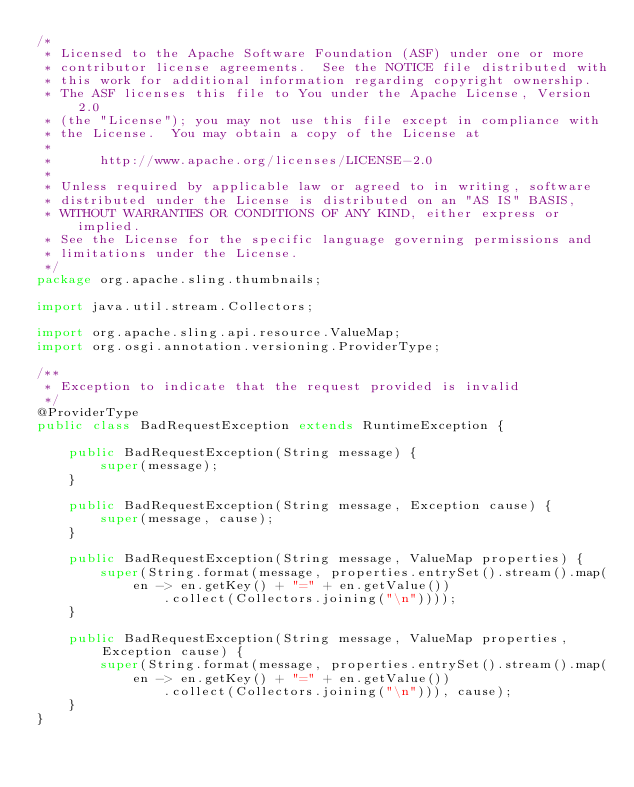<code> <loc_0><loc_0><loc_500><loc_500><_Java_>/*
 * Licensed to the Apache Software Foundation (ASF) under one or more
 * contributor license agreements.  See the NOTICE file distributed with
 * this work for additional information regarding copyright ownership.
 * The ASF licenses this file to You under the Apache License, Version 2.0
 * (the "License"); you may not use this file except in compliance with
 * the License.  You may obtain a copy of the License at
 *
 *      http://www.apache.org/licenses/LICENSE-2.0
 *
 * Unless required by applicable law or agreed to in writing, software
 * distributed under the License is distributed on an "AS IS" BASIS,
 * WITHOUT WARRANTIES OR CONDITIONS OF ANY KIND, either express or implied.
 * See the License for the specific language governing permissions and
 * limitations under the License.
 */
package org.apache.sling.thumbnails;

import java.util.stream.Collectors;

import org.apache.sling.api.resource.ValueMap;
import org.osgi.annotation.versioning.ProviderType;

/**
 * Exception to indicate that the request provided is invalid
 */
@ProviderType
public class BadRequestException extends RuntimeException {

    public BadRequestException(String message) {
        super(message);
    }

    public BadRequestException(String message, Exception cause) {
        super(message, cause);
    }

    public BadRequestException(String message, ValueMap properties) {
        super(String.format(message, properties.entrySet().stream().map(en -> en.getKey() + "=" + en.getValue())
                .collect(Collectors.joining("\n"))));
    }

    public BadRequestException(String message, ValueMap properties, Exception cause) {
        super(String.format(message, properties.entrySet().stream().map(en -> en.getKey() + "=" + en.getValue())
                .collect(Collectors.joining("\n"))), cause);
    }
}</code> 